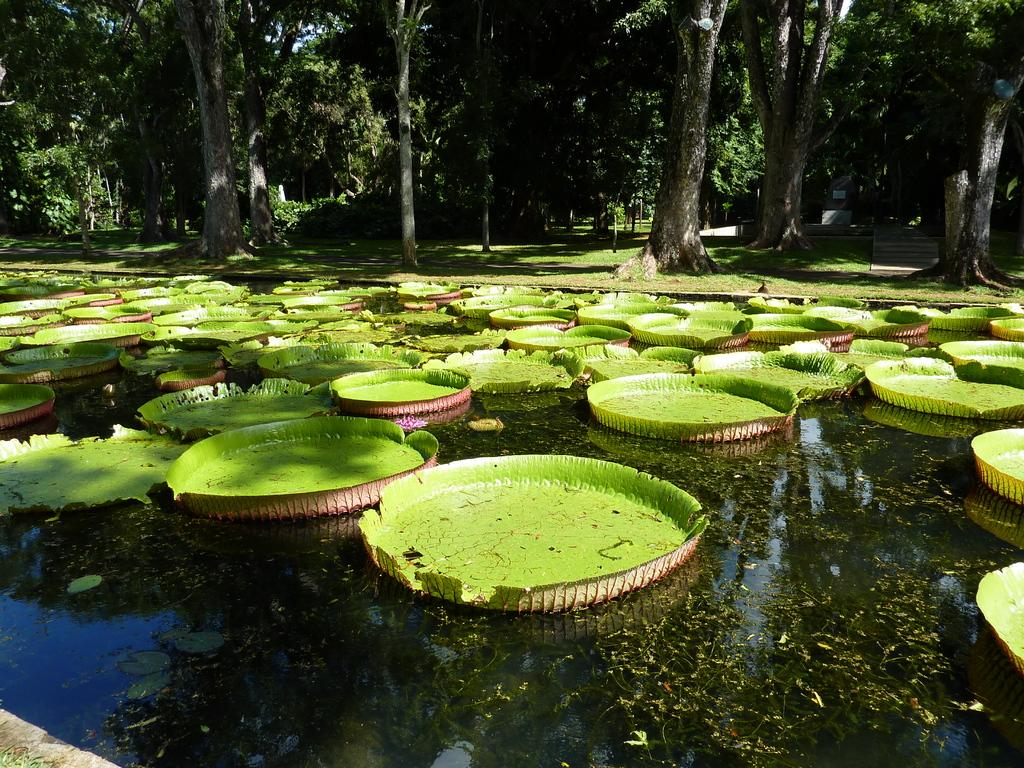What color are the objects in the image? The objects in the image are green. Where are the green objects located? The green objects are on the water. What can be seen in the background of the image? There are trees and grass visible in the background of the image. What type of string is being used by the achiever in the image? There is no achiever or string present in the image. 